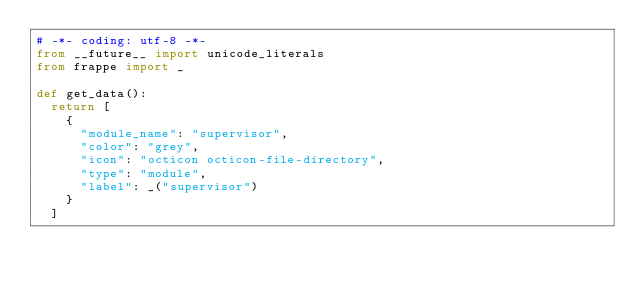Convert code to text. <code><loc_0><loc_0><loc_500><loc_500><_Python_># -*- coding: utf-8 -*-
from __future__ import unicode_literals
from frappe import _

def get_data():
	return [
		{
			"module_name": "supervisor",
			"color": "grey",
			"icon": "octicon octicon-file-directory",
			"type": "module",
			"label": _("supervisor")
		}
	]
</code> 